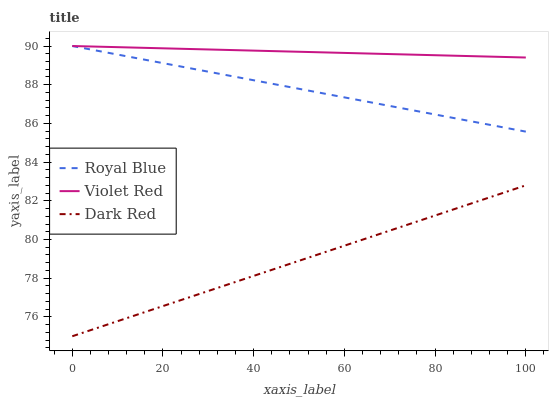Does Dark Red have the minimum area under the curve?
Answer yes or no. Yes. Does Violet Red have the maximum area under the curve?
Answer yes or no. Yes. Does Violet Red have the minimum area under the curve?
Answer yes or no. No. Does Dark Red have the maximum area under the curve?
Answer yes or no. No. Is Royal Blue the smoothest?
Answer yes or no. Yes. Is Dark Red the roughest?
Answer yes or no. Yes. Is Violet Red the smoothest?
Answer yes or no. No. Is Violet Red the roughest?
Answer yes or no. No. Does Dark Red have the lowest value?
Answer yes or no. Yes. Does Violet Red have the lowest value?
Answer yes or no. No. Does Violet Red have the highest value?
Answer yes or no. Yes. Does Dark Red have the highest value?
Answer yes or no. No. Is Dark Red less than Violet Red?
Answer yes or no. Yes. Is Violet Red greater than Dark Red?
Answer yes or no. Yes. Does Violet Red intersect Royal Blue?
Answer yes or no. Yes. Is Violet Red less than Royal Blue?
Answer yes or no. No. Is Violet Red greater than Royal Blue?
Answer yes or no. No. Does Dark Red intersect Violet Red?
Answer yes or no. No. 